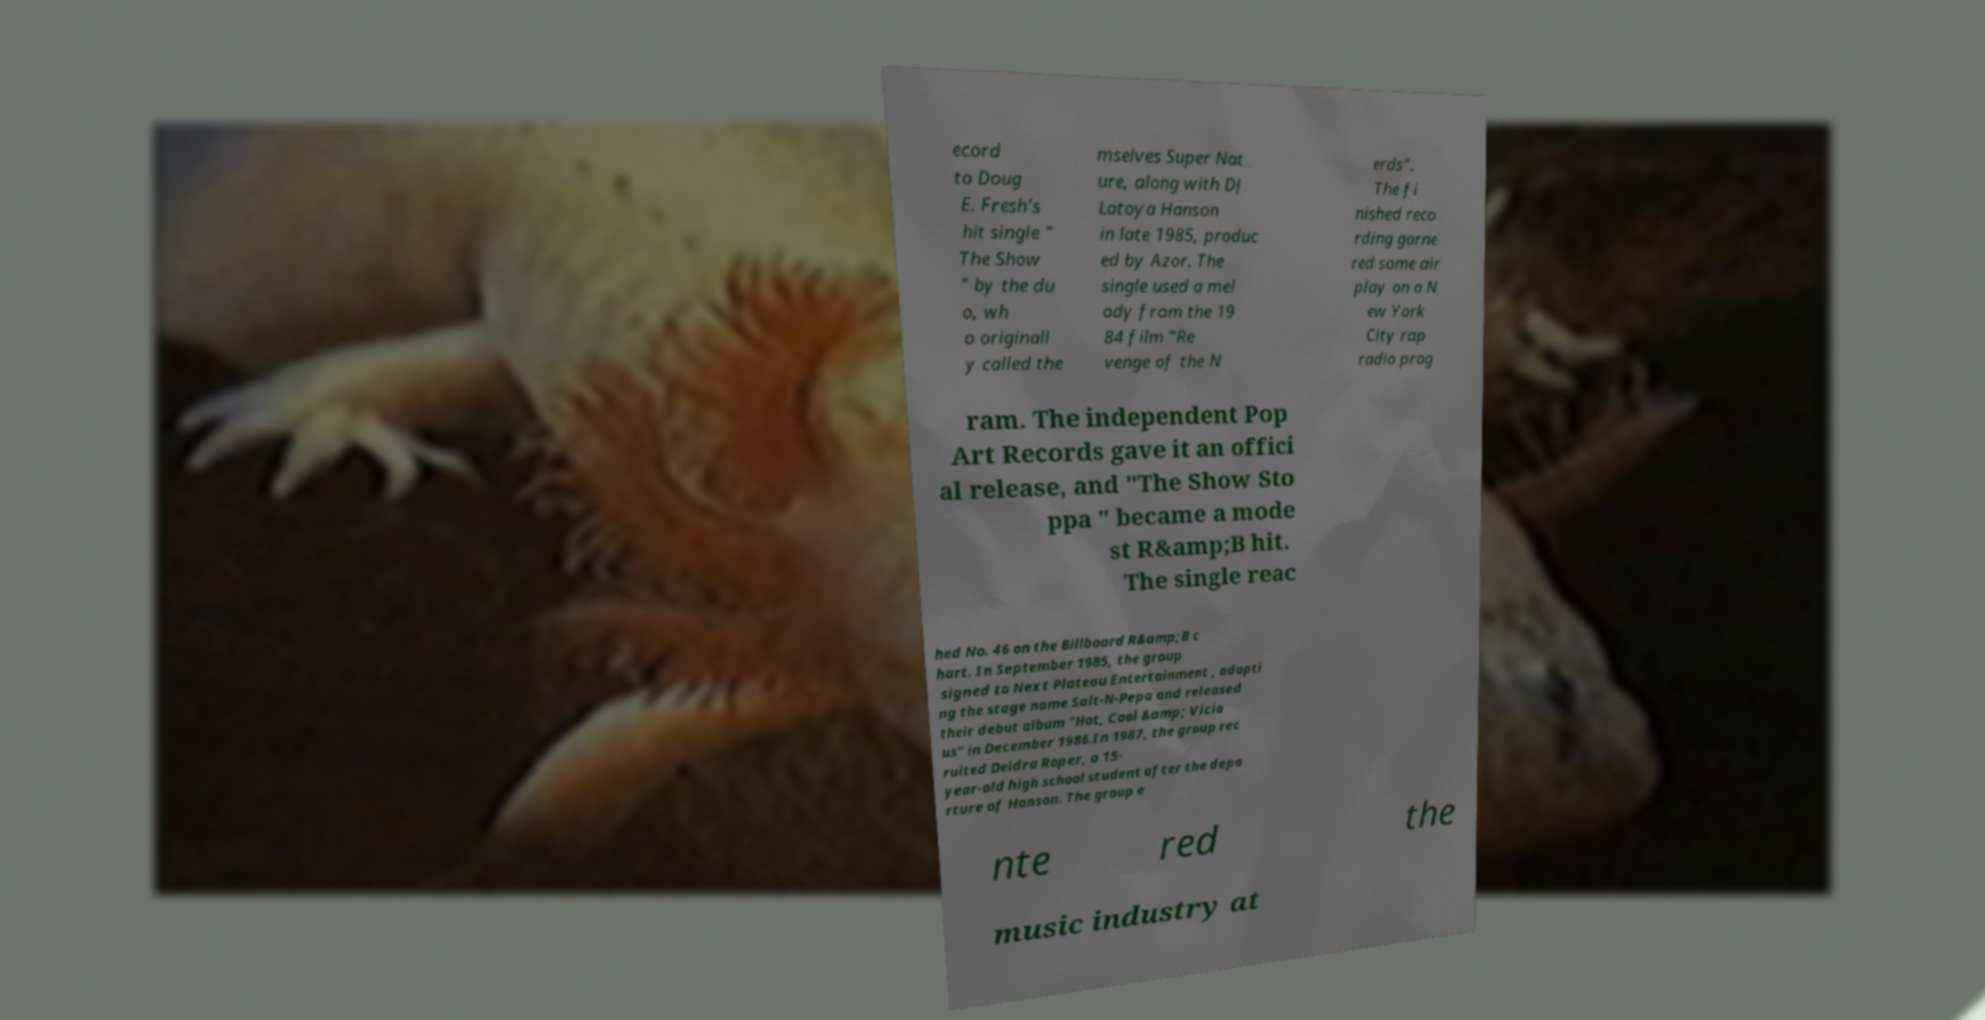I need the written content from this picture converted into text. Can you do that? ecord to Doug E. Fresh's hit single " The Show " by the du o, wh o originall y called the mselves Super Nat ure, along with DJ Latoya Hanson in late 1985, produc ed by Azor. The single used a mel ody from the 19 84 film "Re venge of the N erds". The fi nished reco rding garne red some air play on a N ew York City rap radio prog ram. The independent Pop Art Records gave it an offici al release, and "The Show Sto ppa " became a mode st R&amp;B hit. The single reac hed No. 46 on the Billboard R&amp;B c hart. In September 1985, the group signed to Next Plateau Entertainment , adopti ng the stage name Salt-N-Pepa and released their debut album "Hot, Cool &amp; Vicio us" in December 1986.In 1987, the group rec ruited Deidra Roper, a 15- year-old high school student after the depa rture of Hanson. The group e nte red the music industry at 